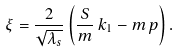<formula> <loc_0><loc_0><loc_500><loc_500>\xi = { \frac { 2 } { \sqrt { \lambda _ { s } } } } \left ( \frac { S } { m } \, k _ { 1 } - m \, p \right ) .</formula> 